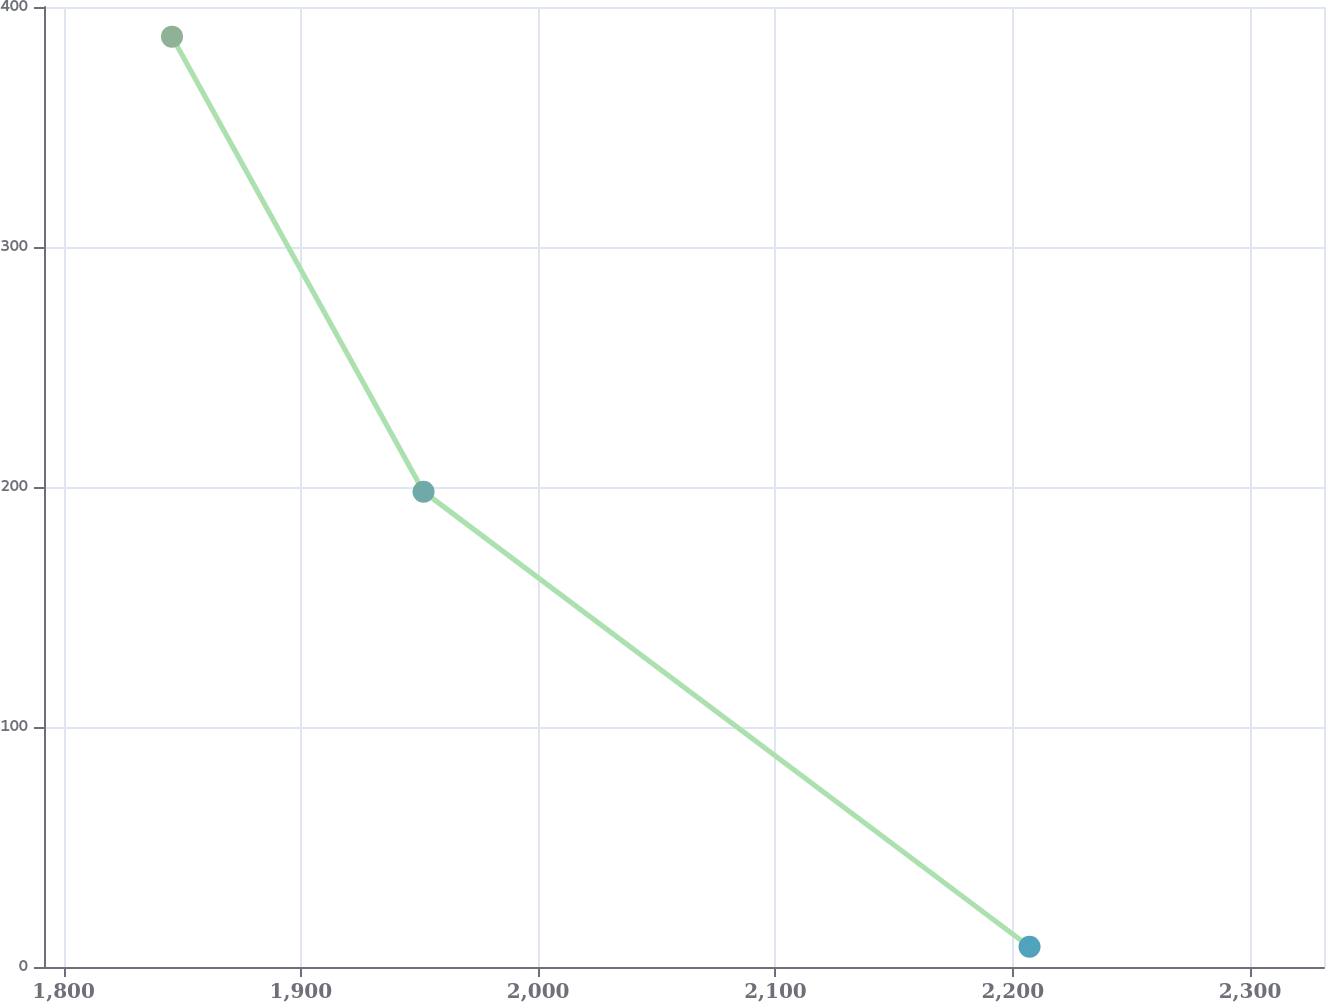Convert chart. <chart><loc_0><loc_0><loc_500><loc_500><line_chart><ecel><fcel>$ 607<nl><fcel>1845.69<fcel>387.65<nl><fcel>1951.7<fcel>198.04<nl><fcel>2207.08<fcel>8.43<nl><fcel>2385.12<fcel>1904.49<nl></chart> 